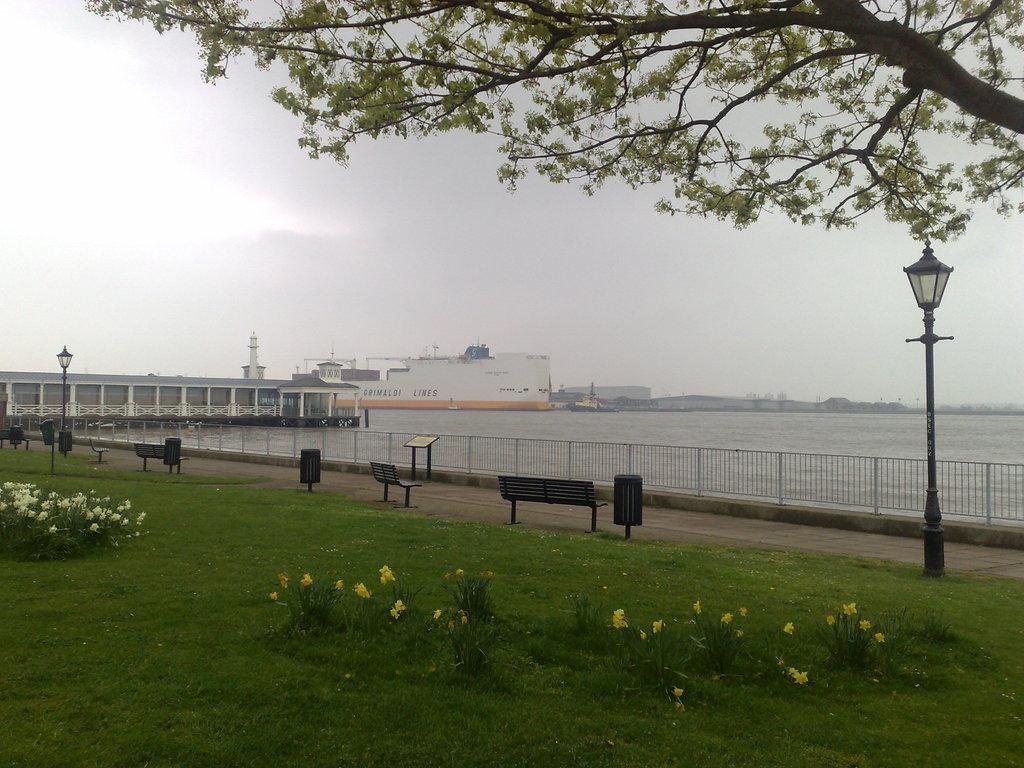Can you describe this image briefly? In front of the image there are flowers on plants on the grass surface, in front of them there are lamp posts, trash cans, and benches. In front of the benches there is a display board with metal rods, behind the board there is a metal rod fence, behind the fence there is water, in the water there are ships. On the other side of the water, there are buildings and trees. At the top of the image there are clouds in the sky and there is a tree. 